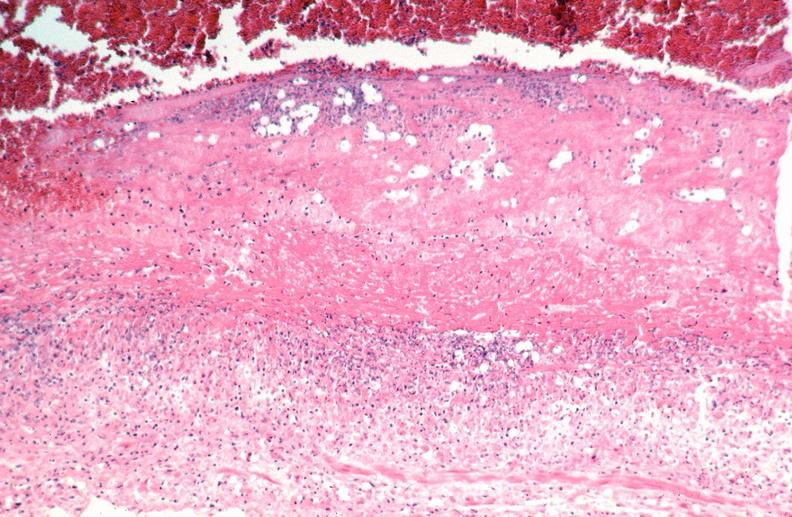s lateral view present?
Answer the question using a single word or phrase. No 